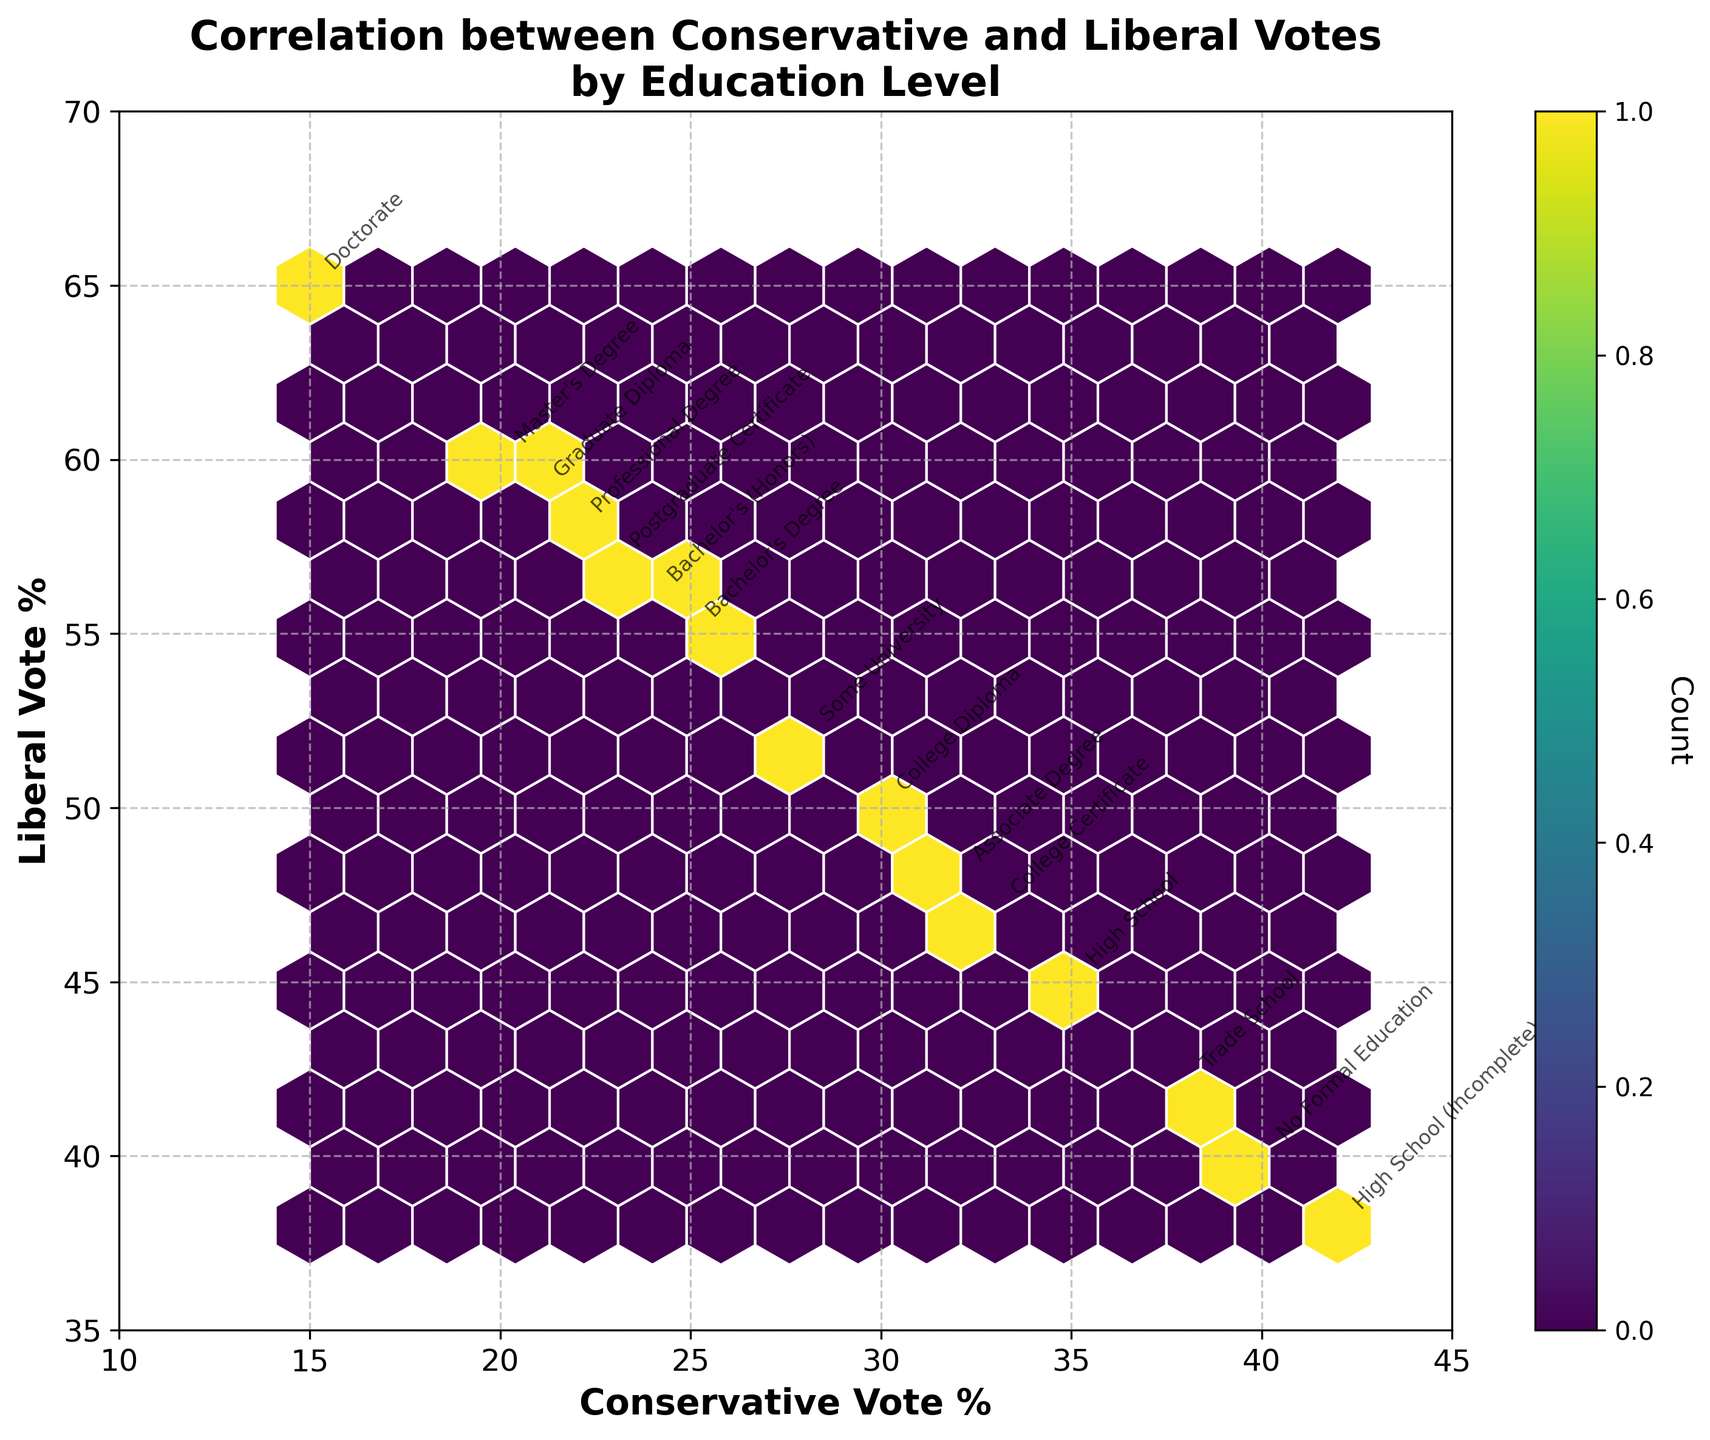1. What is the title of the plot? The title is located at the top of the figure, and it typically summarizes what the plot is about.
Answer: Correlation between Conservative and Liberal Votes by Education Level 2. What are the x-axis and y-axis labels? The x-axis and y-axis labels are found along the horizontal and vertical axes of the plot, respectively, indicating what each axis represents.
Answer: Conservative Vote % and Liberal Vote % 3. How many education levels are annotated on the plot? Count the number of text annotations representing different education levels on the plot.
Answer: 15 4. What is the color scheme of the hexbin plot, and what does it represent? The color scheme can be observed within the hexagons, with darker or lighter shades reflecting different densities of data points.
Answer: Viridis, representing the count of data points 5. Which education level has the highest Conservative vote percentage? Look for the annotation that appears at the highest Conservative vote percentage along the x-axis.
Answer: High School (Incomplete) 6. Which education level has the highest Liberal vote percentage? Identify the annotation at the highest Liberal vote percentage along the y-axis.
Answer: Doctorate 7. Compare the voting percentages between 'College Diploma' and 'Postgraduate Certificate'. Which one has a higher Conservative vote percentage and which one has a higher Liberal vote percentage? Locate the annotations for 'College Diploma' and 'Postgraduate Certificate' and compare their positions on the x-axis for Conservative votes and on the y-axis for Liberal votes.
Answer: Higher Conservative: College Diploma; Higher Liberal: Postgraduate Certificate 8. What is the Conservative and Liberal vote percentage for 'Trade School'? Find the annotation for 'Trade School' and read off the corresponding x (Conservative) and y (Liberal) values.
Answer: 38% Conservative, 42% Liberal 9. What general trend can you observe between Conservative votes and Liberal votes based on the education levels? Observe the general direction and pattern of the annotations on the plot to infer any trends between Conservative and Liberal vote percentages across different education levels.
Answer: As Conservative vote percentage decreases, Liberal vote percentage increases 10. Which education levels have a nearly equal percentage of Conservative and Liberal votes? Look for annotations that are close to the 45-degree line where Conservative vote percentage roughly equals Liberal vote percentage.
Answer: No Formal Education, College Certificate 